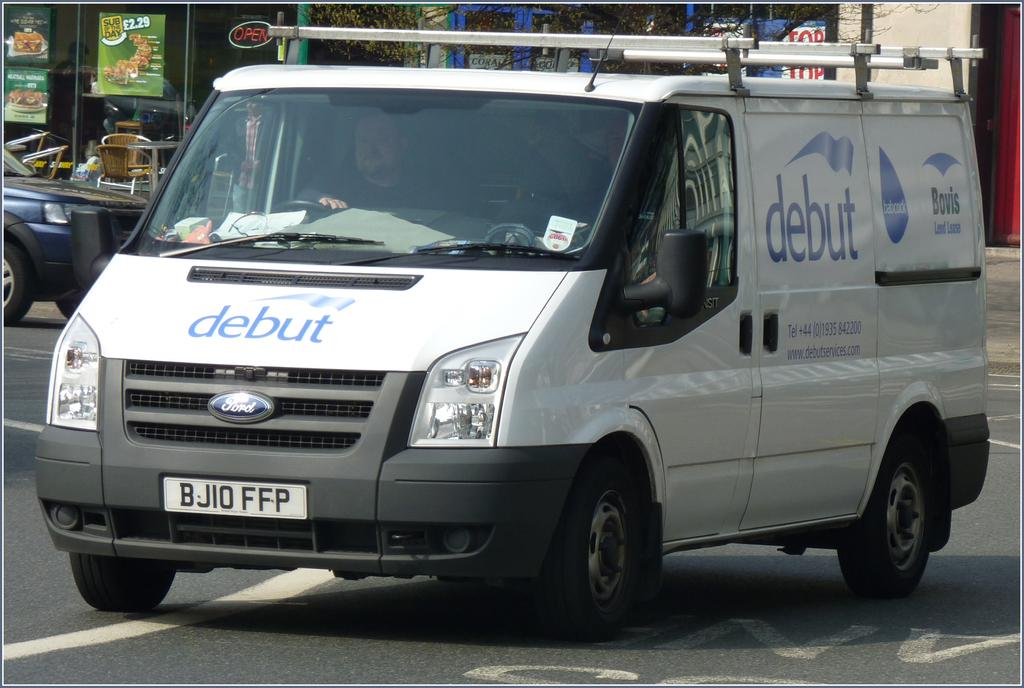Provide a one-sentence caption for the provided image. The white van belongs to Debut Services and provides phone number and website information for the company. 